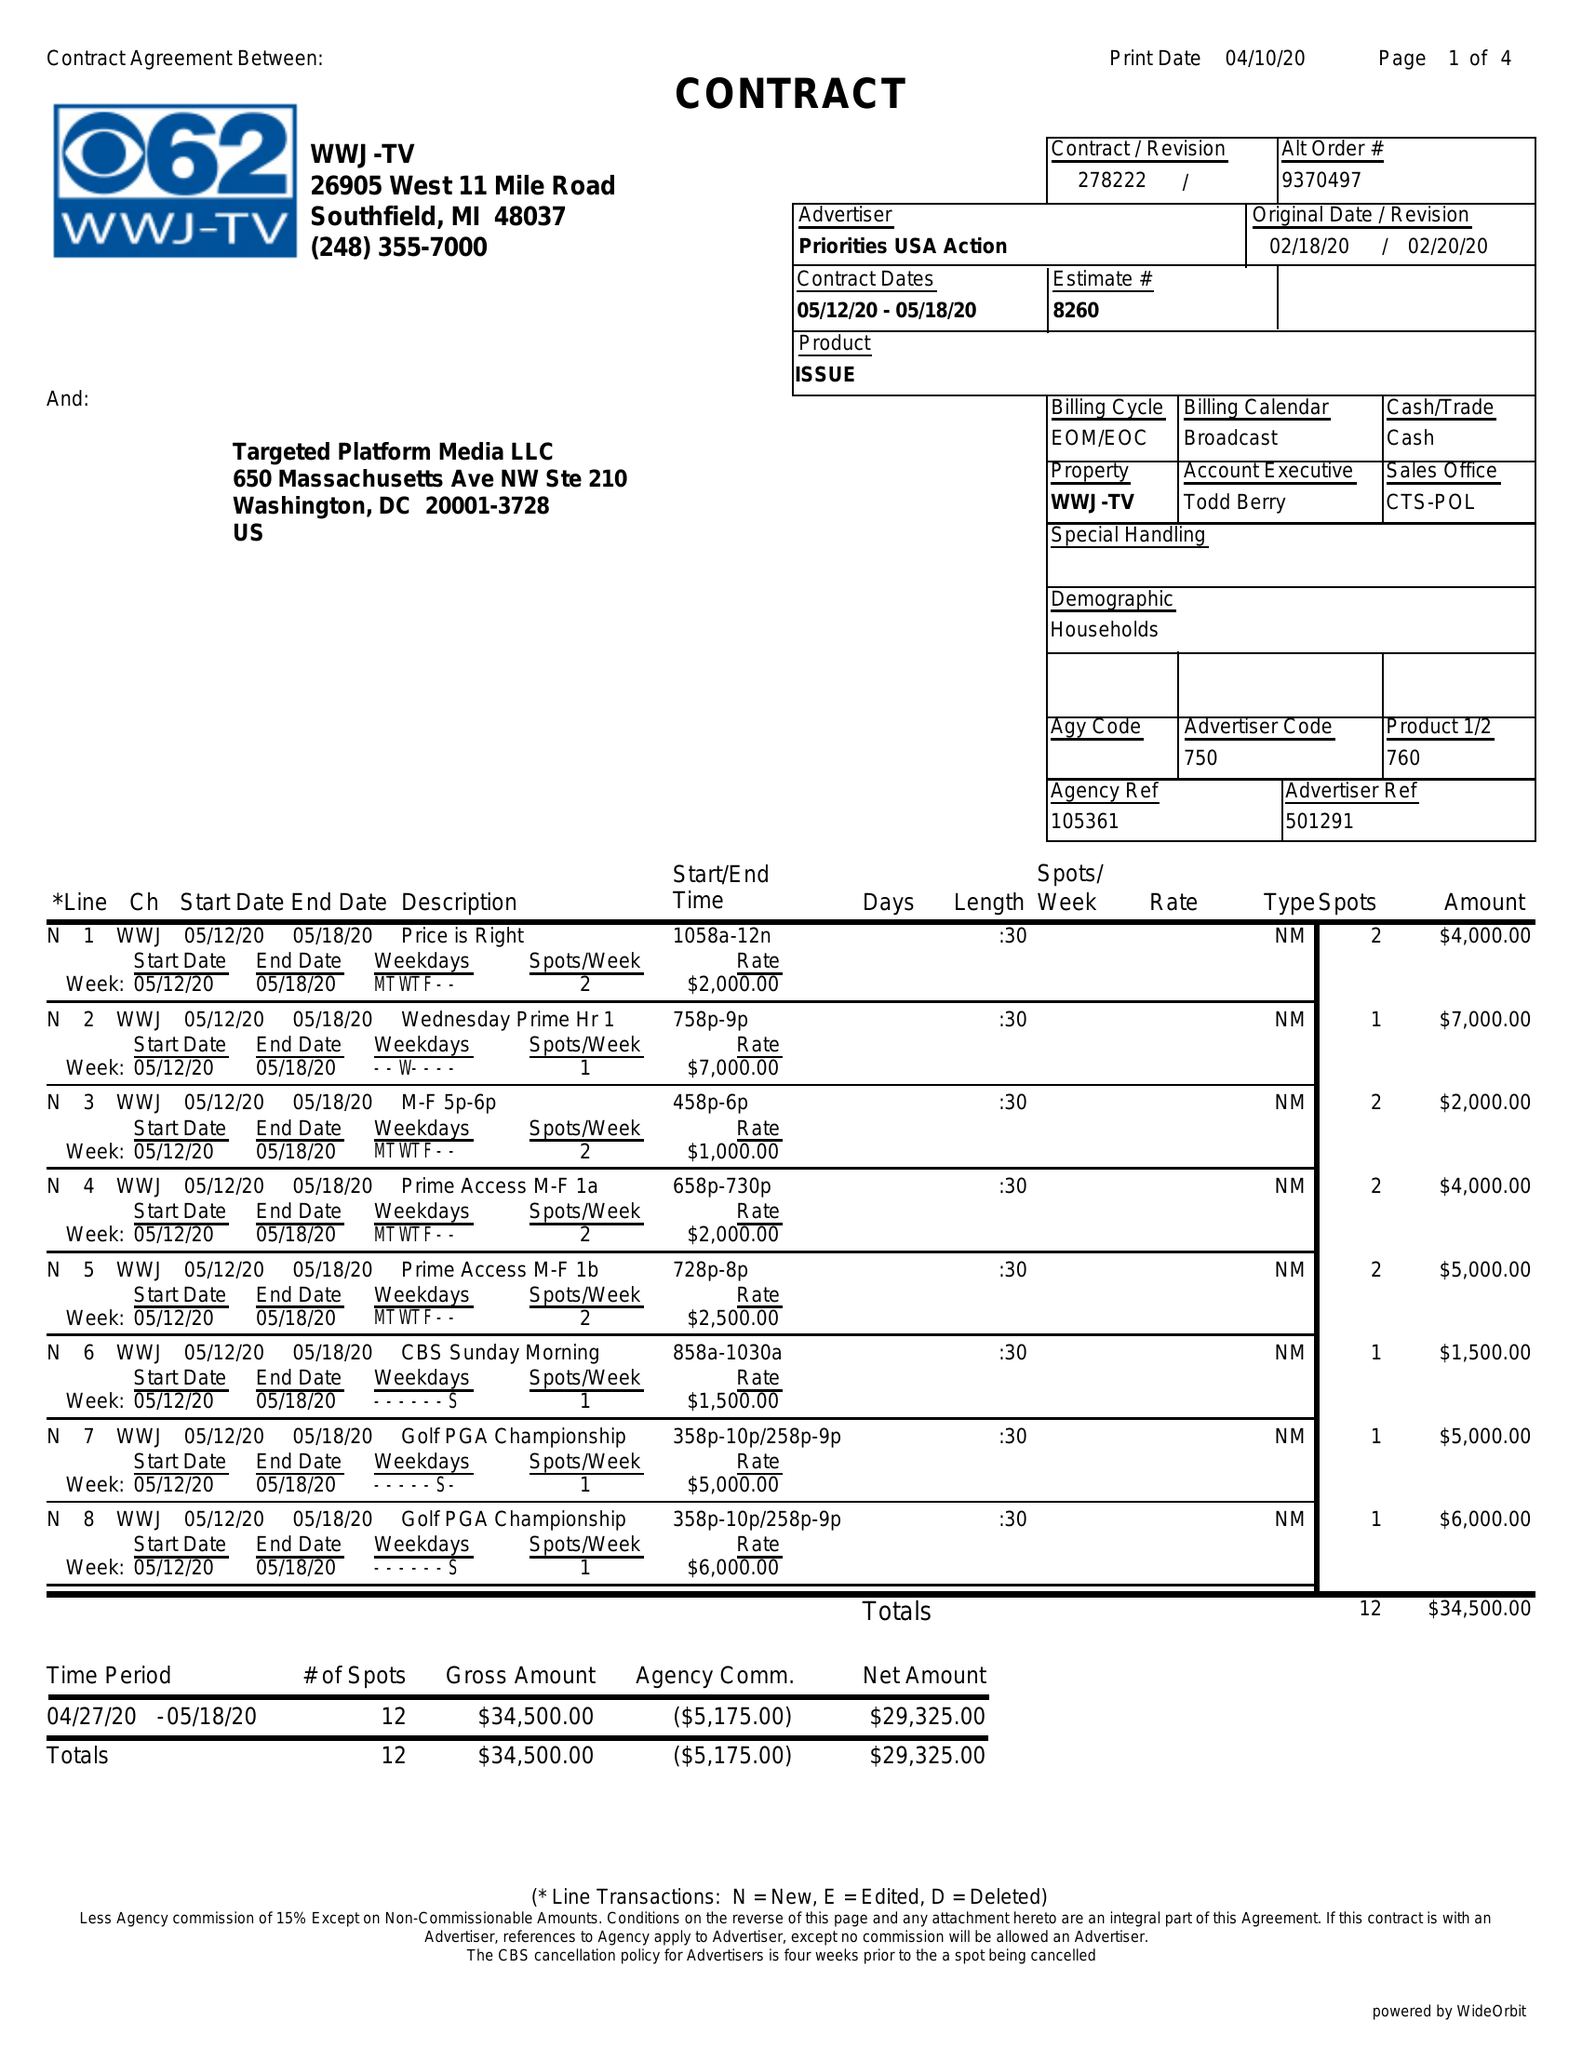What is the value for the advertiser?
Answer the question using a single word or phrase. PRIORITIES USA ACTION 